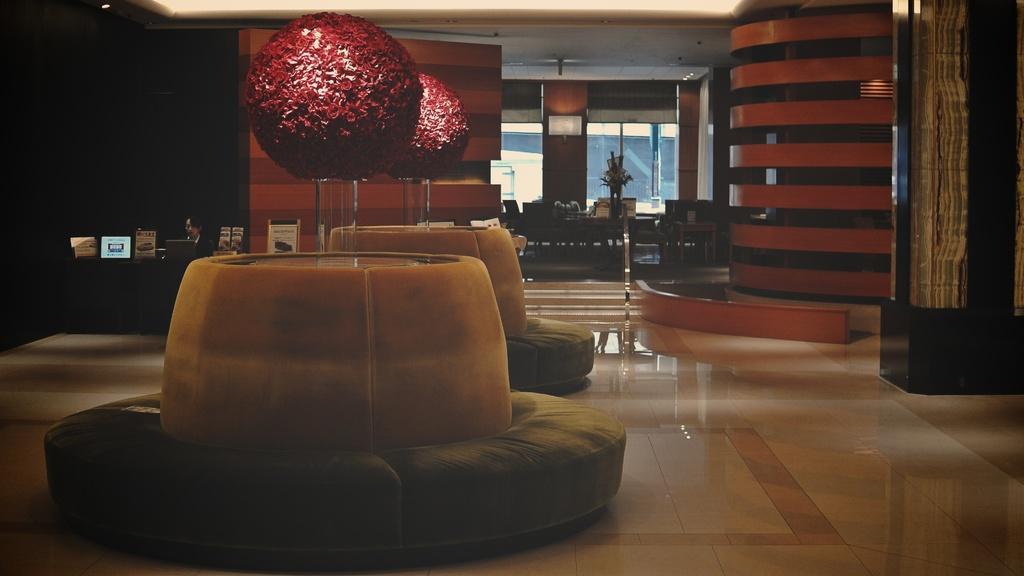Could you give a brief overview of what you see in this image? In this image we can see some sofas on the floor and decors on it. We can also see a group of chairs, a plant in a pot, a television on a wall and a roof with some ceiling lights. On the left side we can see a person sitting beside a table containing some laptops on it. 